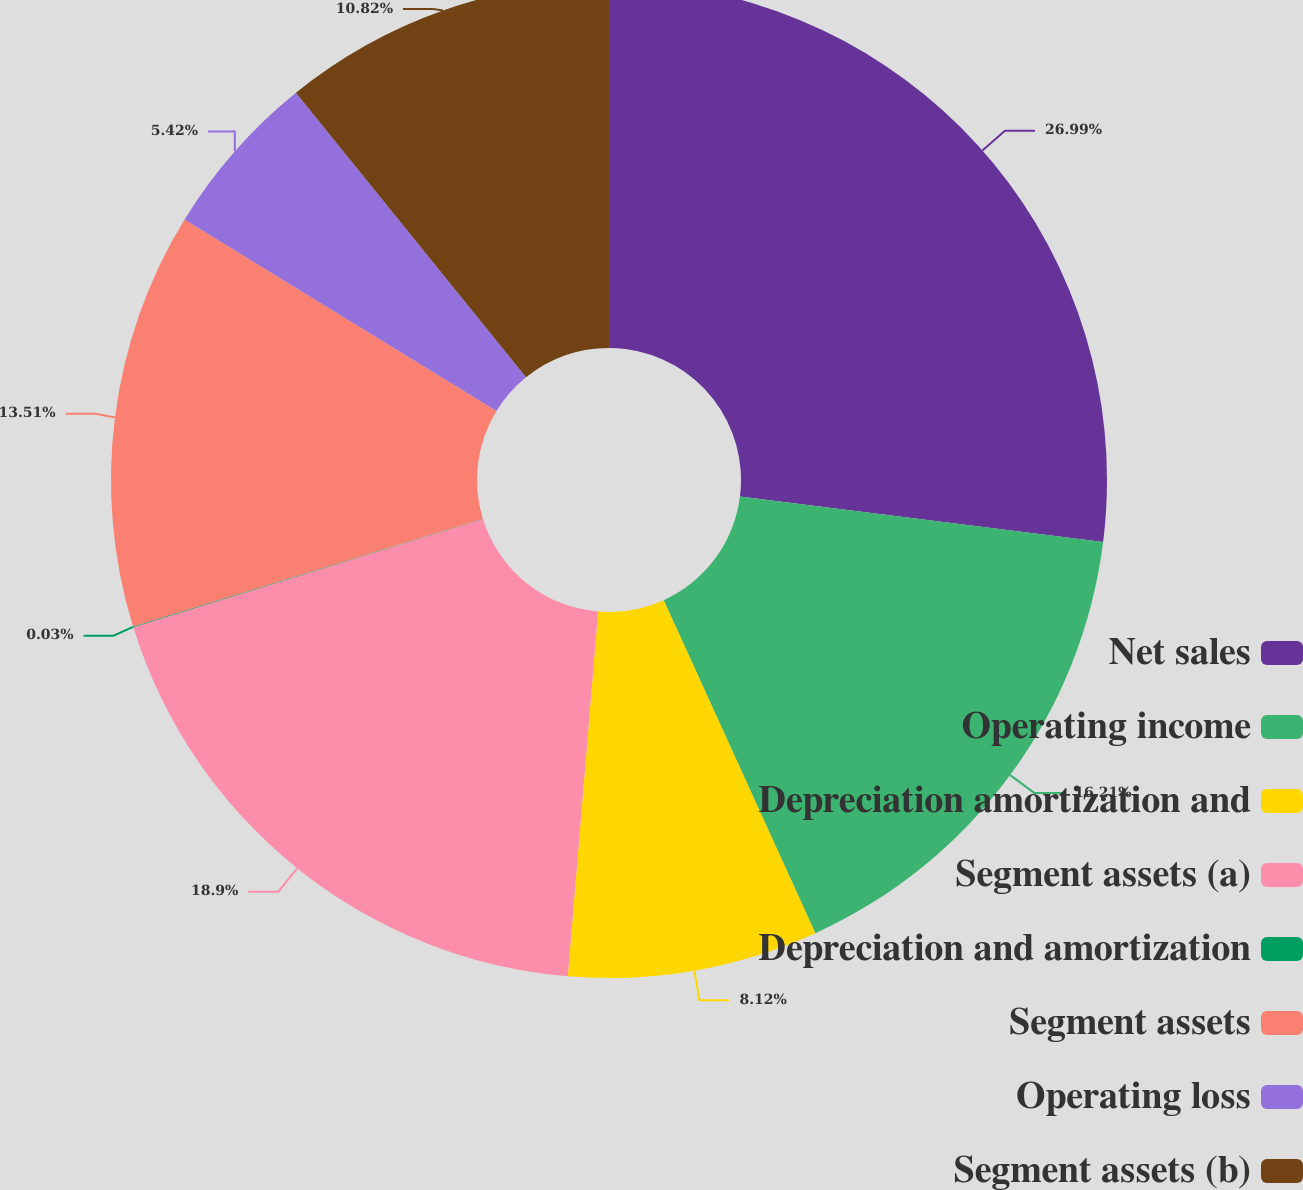Convert chart. <chart><loc_0><loc_0><loc_500><loc_500><pie_chart><fcel>Net sales<fcel>Operating income<fcel>Depreciation amortization and<fcel>Segment assets (a)<fcel>Depreciation and amortization<fcel>Segment assets<fcel>Operating loss<fcel>Segment assets (b)<nl><fcel>26.99%<fcel>16.21%<fcel>8.12%<fcel>18.9%<fcel>0.03%<fcel>13.51%<fcel>5.42%<fcel>10.82%<nl></chart> 